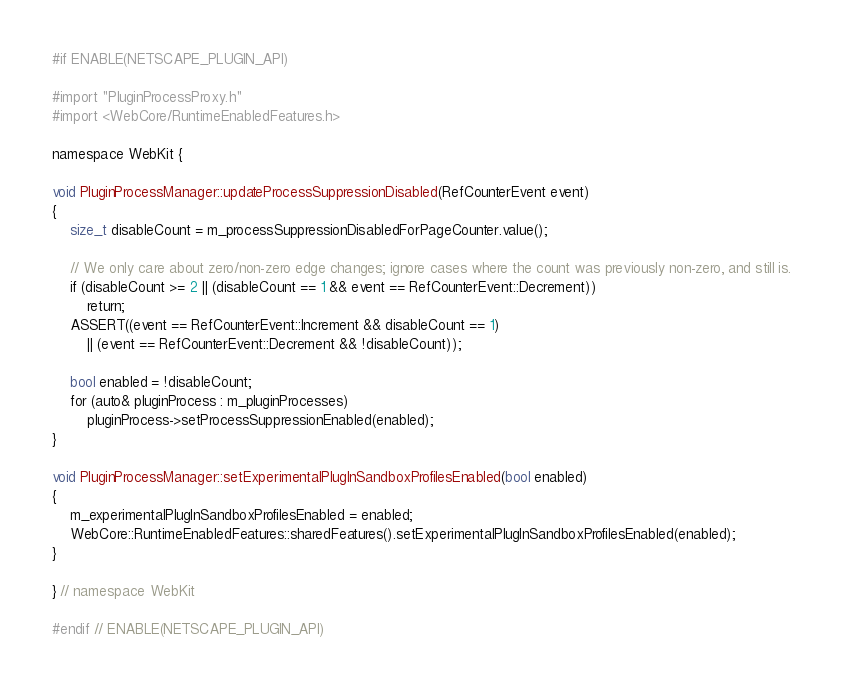Convert code to text. <code><loc_0><loc_0><loc_500><loc_500><_ObjectiveC_>
#if ENABLE(NETSCAPE_PLUGIN_API)

#import "PluginProcessProxy.h"
#import <WebCore/RuntimeEnabledFeatures.h>

namespace WebKit {

void PluginProcessManager::updateProcessSuppressionDisabled(RefCounterEvent event)
{
    size_t disableCount = m_processSuppressionDisabledForPageCounter.value();

    // We only care about zero/non-zero edge changes; ignore cases where the count was previously non-zero, and still is.
    if (disableCount >= 2 || (disableCount == 1 && event == RefCounterEvent::Decrement))
        return;
    ASSERT((event == RefCounterEvent::Increment && disableCount == 1)
        || (event == RefCounterEvent::Decrement && !disableCount));

    bool enabled = !disableCount;
    for (auto& pluginProcess : m_pluginProcesses)
        pluginProcess->setProcessSuppressionEnabled(enabled);
}

void PluginProcessManager::setExperimentalPlugInSandboxProfilesEnabled(bool enabled)
{
    m_experimentalPlugInSandboxProfilesEnabled = enabled;
    WebCore::RuntimeEnabledFeatures::sharedFeatures().setExperimentalPlugInSandboxProfilesEnabled(enabled);
}

} // namespace WebKit

#endif // ENABLE(NETSCAPE_PLUGIN_API)
</code> 